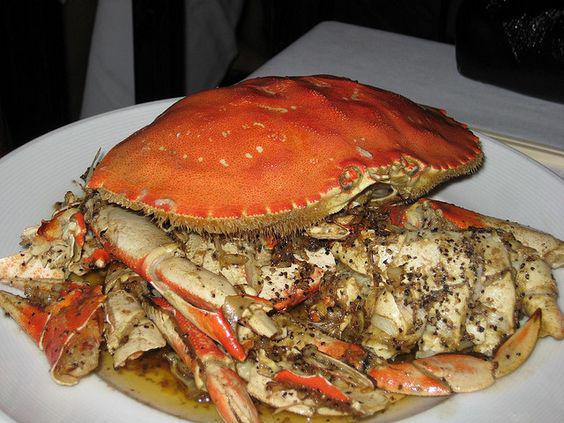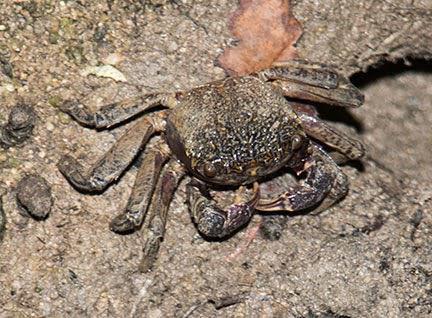The first image is the image on the left, the second image is the image on the right. Considering the images on both sides, is "A single crab sits on a sediment surface in the image on the right." valid? Answer yes or no. Yes. The first image is the image on the left, the second image is the image on the right. Evaluate the accuracy of this statement regarding the images: "There are exactly two live crabs.". Is it true? Answer yes or no. No. 